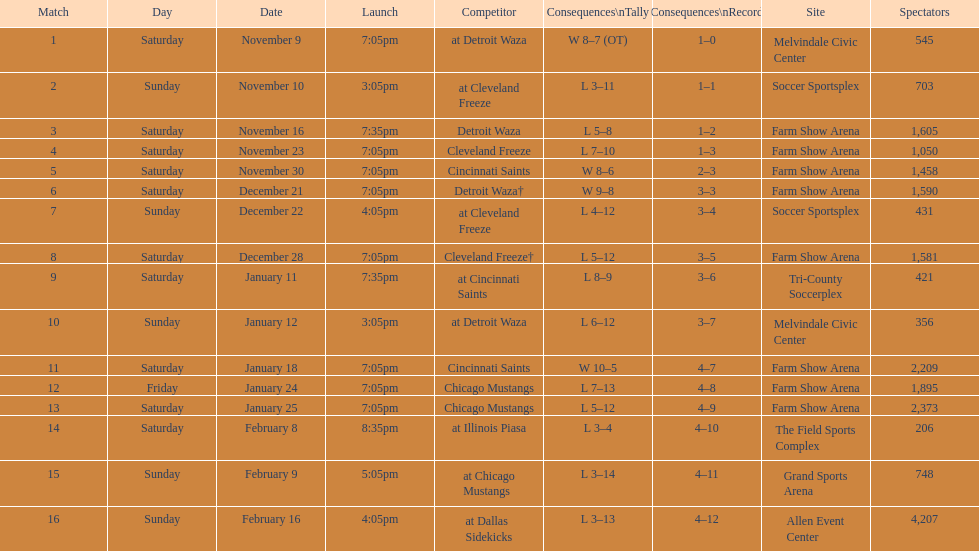What was the location before tri-county soccerplex? Farm Show Arena. 